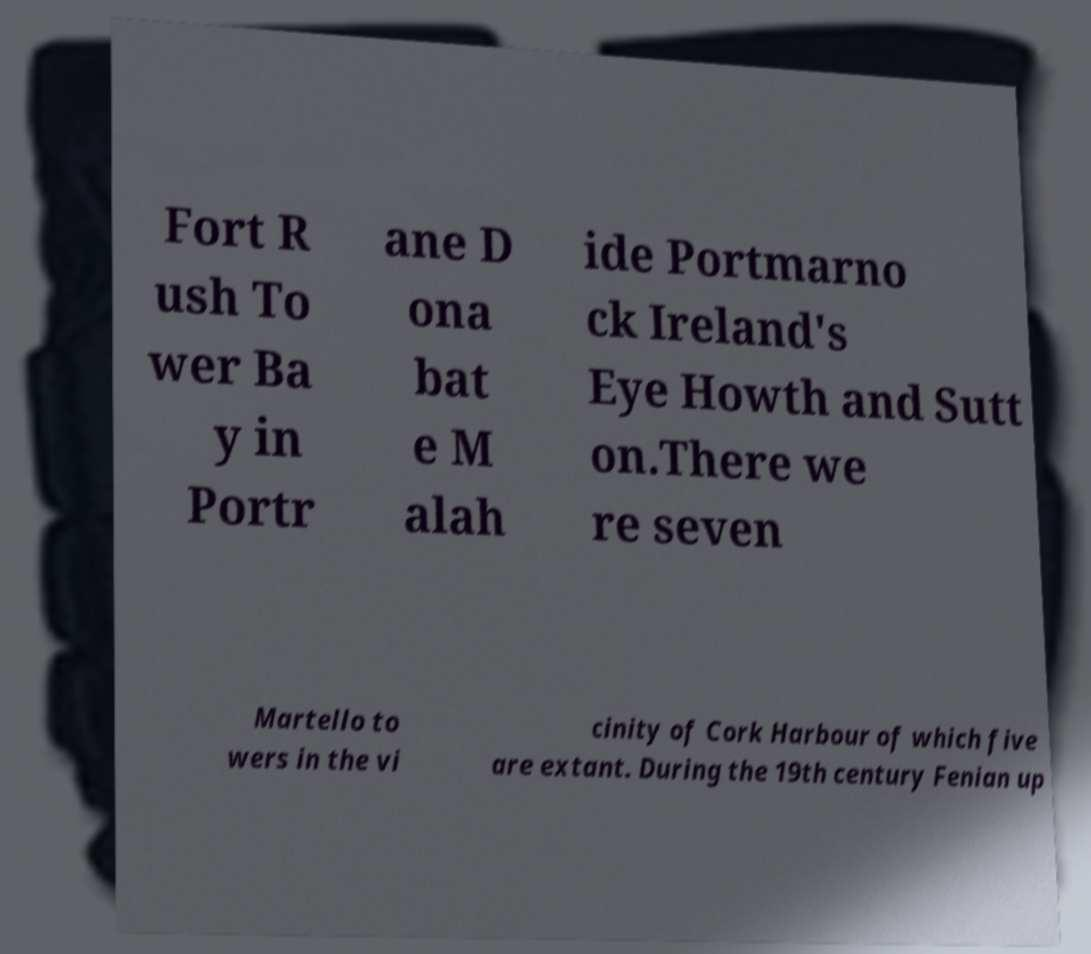What messages or text are displayed in this image? I need them in a readable, typed format. Fort R ush To wer Ba y in Portr ane D ona bat e M alah ide Portmarno ck Ireland's Eye Howth and Sutt on.There we re seven Martello to wers in the vi cinity of Cork Harbour of which five are extant. During the 19th century Fenian up 